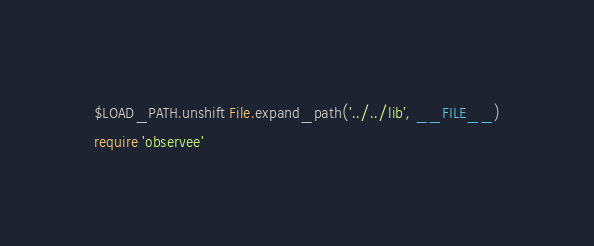Convert code to text. <code><loc_0><loc_0><loc_500><loc_500><_Ruby_>$LOAD_PATH.unshift File.expand_path('../../lib', __FILE__)
require 'observee'
</code> 